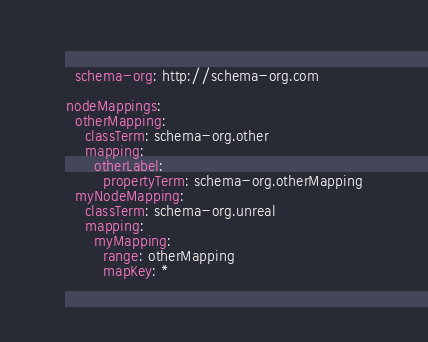Convert code to text. <code><loc_0><loc_0><loc_500><loc_500><_YAML_>  schema-org: http://schema-org.com

nodeMappings:
  otherMapping:
    classTerm: schema-org.other
    mapping:
      otherLabel:
        propertyTerm: schema-org.otherMapping
  myNodeMapping:
    classTerm: schema-org.unreal
    mapping:
      myMapping:
        range: otherMapping
        mapKey: *</code> 